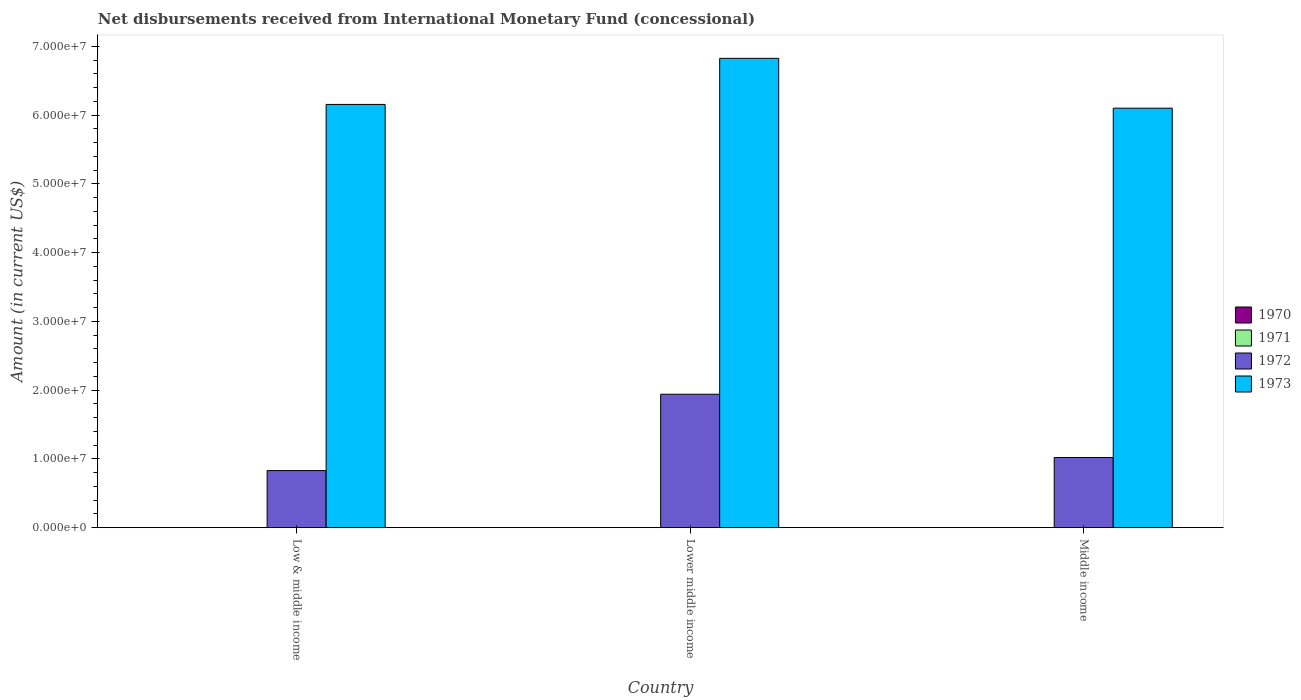How many different coloured bars are there?
Offer a very short reply. 2. Are the number of bars per tick equal to the number of legend labels?
Your answer should be compact. No. How many bars are there on the 2nd tick from the left?
Your answer should be compact. 2. What is the label of the 3rd group of bars from the left?
Offer a terse response. Middle income. In how many cases, is the number of bars for a given country not equal to the number of legend labels?
Provide a short and direct response. 3. What is the amount of disbursements received from International Monetary Fund in 1973 in Middle income?
Make the answer very short. 6.10e+07. Across all countries, what is the maximum amount of disbursements received from International Monetary Fund in 1973?
Your response must be concise. 6.83e+07. Across all countries, what is the minimum amount of disbursements received from International Monetary Fund in 1972?
Your response must be concise. 8.30e+06. In which country was the amount of disbursements received from International Monetary Fund in 1972 maximum?
Offer a very short reply. Lower middle income. What is the total amount of disbursements received from International Monetary Fund in 1973 in the graph?
Keep it short and to the point. 1.91e+08. What is the difference between the amount of disbursements received from International Monetary Fund in 1972 in Lower middle income and that in Middle income?
Make the answer very short. 9.21e+06. What is the difference between the amount of disbursements received from International Monetary Fund in 1972 in Lower middle income and the amount of disbursements received from International Monetary Fund in 1973 in Middle income?
Your answer should be compact. -4.16e+07. What is the difference between the amount of disbursements received from International Monetary Fund of/in 1972 and amount of disbursements received from International Monetary Fund of/in 1973 in Lower middle income?
Keep it short and to the point. -4.89e+07. In how many countries, is the amount of disbursements received from International Monetary Fund in 1971 greater than 8000000 US$?
Provide a short and direct response. 0. What is the ratio of the amount of disbursements received from International Monetary Fund in 1973 in Low & middle income to that in Lower middle income?
Offer a very short reply. 0.9. Is the difference between the amount of disbursements received from International Monetary Fund in 1972 in Lower middle income and Middle income greater than the difference between the amount of disbursements received from International Monetary Fund in 1973 in Lower middle income and Middle income?
Offer a very short reply. Yes. What is the difference between the highest and the second highest amount of disbursements received from International Monetary Fund in 1972?
Offer a terse response. 9.21e+06. What is the difference between the highest and the lowest amount of disbursements received from International Monetary Fund in 1973?
Your answer should be very brief. 7.25e+06. Is it the case that in every country, the sum of the amount of disbursements received from International Monetary Fund in 1972 and amount of disbursements received from International Monetary Fund in 1971 is greater than the sum of amount of disbursements received from International Monetary Fund in 1970 and amount of disbursements received from International Monetary Fund in 1973?
Make the answer very short. No. How many bars are there?
Your answer should be very brief. 6. Are the values on the major ticks of Y-axis written in scientific E-notation?
Make the answer very short. Yes. Does the graph contain grids?
Ensure brevity in your answer.  No. Where does the legend appear in the graph?
Make the answer very short. Center right. How many legend labels are there?
Offer a very short reply. 4. What is the title of the graph?
Ensure brevity in your answer.  Net disbursements received from International Monetary Fund (concessional). What is the label or title of the Y-axis?
Keep it short and to the point. Amount (in current US$). What is the Amount (in current US$) of 1970 in Low & middle income?
Your answer should be very brief. 0. What is the Amount (in current US$) in 1971 in Low & middle income?
Make the answer very short. 0. What is the Amount (in current US$) of 1972 in Low & middle income?
Provide a succinct answer. 8.30e+06. What is the Amount (in current US$) in 1973 in Low & middle income?
Provide a short and direct response. 6.16e+07. What is the Amount (in current US$) of 1971 in Lower middle income?
Ensure brevity in your answer.  0. What is the Amount (in current US$) in 1972 in Lower middle income?
Your response must be concise. 1.94e+07. What is the Amount (in current US$) in 1973 in Lower middle income?
Offer a very short reply. 6.83e+07. What is the Amount (in current US$) of 1970 in Middle income?
Give a very brief answer. 0. What is the Amount (in current US$) of 1971 in Middle income?
Provide a short and direct response. 0. What is the Amount (in current US$) of 1972 in Middle income?
Keep it short and to the point. 1.02e+07. What is the Amount (in current US$) of 1973 in Middle income?
Make the answer very short. 6.10e+07. Across all countries, what is the maximum Amount (in current US$) of 1972?
Give a very brief answer. 1.94e+07. Across all countries, what is the maximum Amount (in current US$) in 1973?
Give a very brief answer. 6.83e+07. Across all countries, what is the minimum Amount (in current US$) in 1972?
Keep it short and to the point. 8.30e+06. Across all countries, what is the minimum Amount (in current US$) in 1973?
Ensure brevity in your answer.  6.10e+07. What is the total Amount (in current US$) of 1970 in the graph?
Provide a succinct answer. 0. What is the total Amount (in current US$) in 1972 in the graph?
Provide a short and direct response. 3.79e+07. What is the total Amount (in current US$) of 1973 in the graph?
Give a very brief answer. 1.91e+08. What is the difference between the Amount (in current US$) of 1972 in Low & middle income and that in Lower middle income?
Provide a short and direct response. -1.11e+07. What is the difference between the Amount (in current US$) in 1973 in Low & middle income and that in Lower middle income?
Give a very brief answer. -6.70e+06. What is the difference between the Amount (in current US$) in 1972 in Low & middle income and that in Middle income?
Provide a short and direct response. -1.90e+06. What is the difference between the Amount (in current US$) in 1973 in Low & middle income and that in Middle income?
Offer a very short reply. 5.46e+05. What is the difference between the Amount (in current US$) of 1972 in Lower middle income and that in Middle income?
Your answer should be compact. 9.21e+06. What is the difference between the Amount (in current US$) in 1973 in Lower middle income and that in Middle income?
Ensure brevity in your answer.  7.25e+06. What is the difference between the Amount (in current US$) of 1972 in Low & middle income and the Amount (in current US$) of 1973 in Lower middle income?
Give a very brief answer. -6.00e+07. What is the difference between the Amount (in current US$) in 1972 in Low & middle income and the Amount (in current US$) in 1973 in Middle income?
Ensure brevity in your answer.  -5.27e+07. What is the difference between the Amount (in current US$) of 1972 in Lower middle income and the Amount (in current US$) of 1973 in Middle income?
Keep it short and to the point. -4.16e+07. What is the average Amount (in current US$) of 1970 per country?
Your answer should be compact. 0. What is the average Amount (in current US$) of 1971 per country?
Ensure brevity in your answer.  0. What is the average Amount (in current US$) in 1972 per country?
Your answer should be very brief. 1.26e+07. What is the average Amount (in current US$) in 1973 per country?
Offer a very short reply. 6.36e+07. What is the difference between the Amount (in current US$) in 1972 and Amount (in current US$) in 1973 in Low & middle income?
Provide a short and direct response. -5.33e+07. What is the difference between the Amount (in current US$) of 1972 and Amount (in current US$) of 1973 in Lower middle income?
Make the answer very short. -4.89e+07. What is the difference between the Amount (in current US$) in 1972 and Amount (in current US$) in 1973 in Middle income?
Provide a succinct answer. -5.08e+07. What is the ratio of the Amount (in current US$) in 1972 in Low & middle income to that in Lower middle income?
Provide a succinct answer. 0.43. What is the ratio of the Amount (in current US$) in 1973 in Low & middle income to that in Lower middle income?
Give a very brief answer. 0.9. What is the ratio of the Amount (in current US$) in 1972 in Low & middle income to that in Middle income?
Offer a very short reply. 0.81. What is the ratio of the Amount (in current US$) in 1973 in Low & middle income to that in Middle income?
Ensure brevity in your answer.  1.01. What is the ratio of the Amount (in current US$) of 1972 in Lower middle income to that in Middle income?
Offer a very short reply. 1.9. What is the ratio of the Amount (in current US$) of 1973 in Lower middle income to that in Middle income?
Your answer should be very brief. 1.12. What is the difference between the highest and the second highest Amount (in current US$) in 1972?
Provide a short and direct response. 9.21e+06. What is the difference between the highest and the second highest Amount (in current US$) in 1973?
Keep it short and to the point. 6.70e+06. What is the difference between the highest and the lowest Amount (in current US$) of 1972?
Your answer should be compact. 1.11e+07. What is the difference between the highest and the lowest Amount (in current US$) of 1973?
Provide a short and direct response. 7.25e+06. 